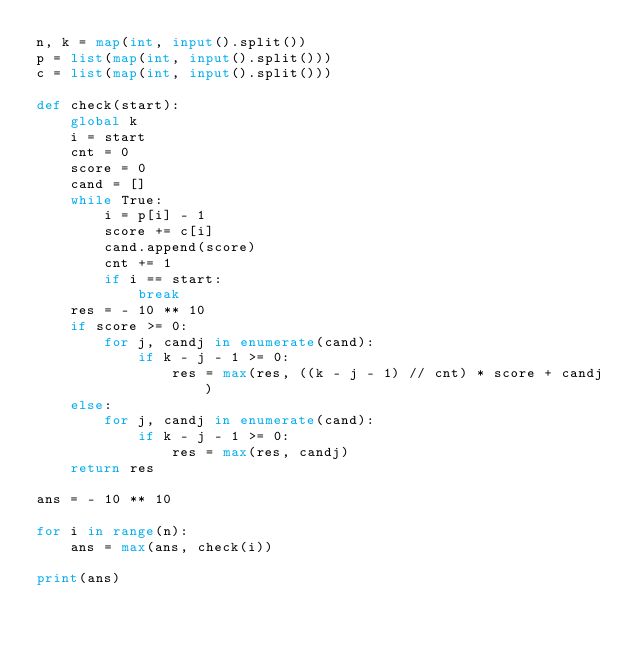Convert code to text. <code><loc_0><loc_0><loc_500><loc_500><_Python_>n, k = map(int, input().split())
p = list(map(int, input().split()))
c = list(map(int, input().split()))

def check(start):
    global k
    i = start
    cnt = 0
    score = 0
    cand = []
    while True:
        i = p[i] - 1
        score += c[i]
        cand.append(score)
        cnt += 1
        if i == start:
            break
    res = - 10 ** 10
    if score >= 0:
        for j, candj in enumerate(cand):
            if k - j - 1 >= 0:
                res = max(res, ((k - j - 1) // cnt) * score + candj)
    else:
        for j, candj in enumerate(cand):
            if k - j - 1 >= 0:
                res = max(res, candj)
    return res

ans = - 10 ** 10

for i in range(n):
    ans = max(ans, check(i))

print(ans)

    </code> 